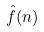Convert formula to latex. <formula><loc_0><loc_0><loc_500><loc_500>\hat { f } ( n )</formula> 